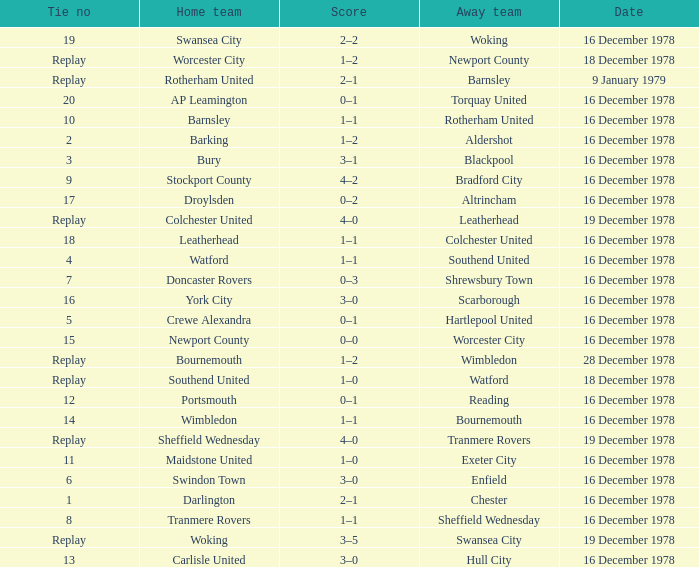What is the tie no for the away team altrincham? 17.0. 